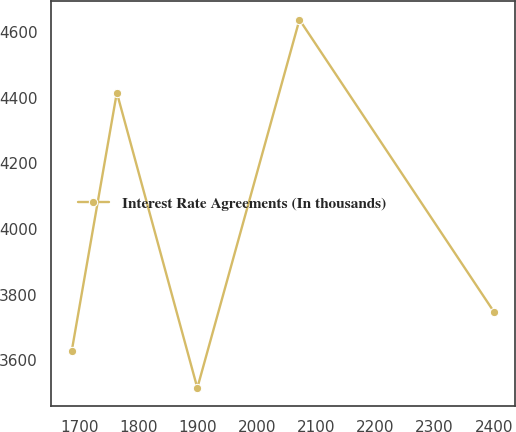Convert chart. <chart><loc_0><loc_0><loc_500><loc_500><line_chart><ecel><fcel>Interest Rate Agreements (In thousands)<nl><fcel>1687.15<fcel>3628.24<nl><fcel>1763.38<fcel>4415.87<nl><fcel>1899.35<fcel>3516.04<nl><fcel>2071.88<fcel>4638.05<nl><fcel>2400.6<fcel>3747.42<nl></chart> 